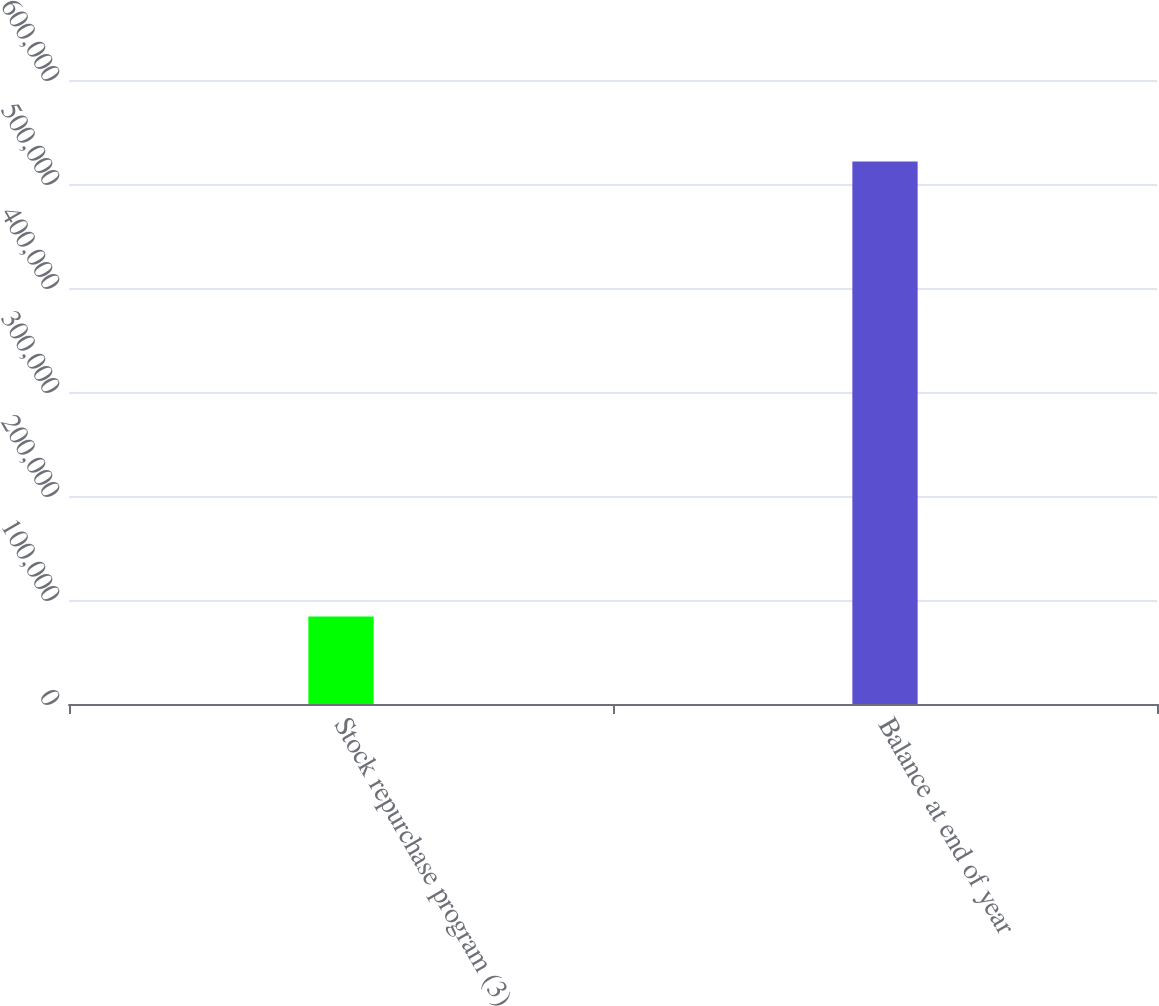Convert chart. <chart><loc_0><loc_0><loc_500><loc_500><bar_chart><fcel>Stock repurchase program (3)<fcel>Balance at end of year<nl><fcel>84241<fcel>521543<nl></chart> 